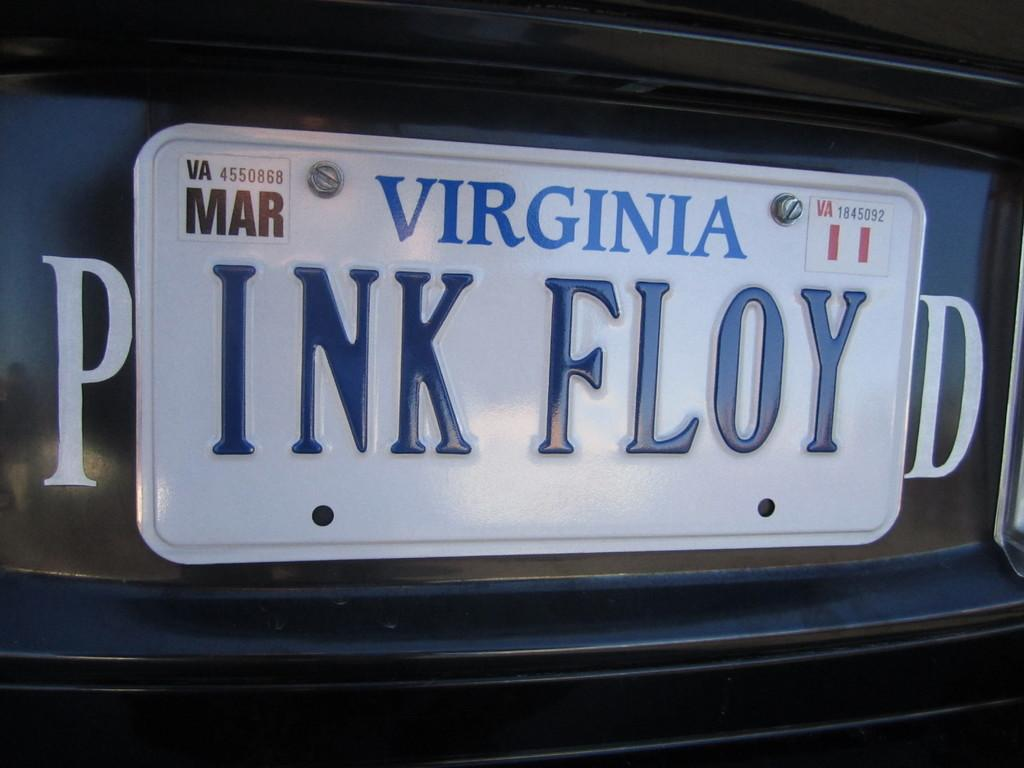<image>
Create a compact narrative representing the image presented. White car license plate from the state of Virginia 